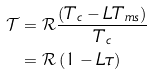Convert formula to latex. <formula><loc_0><loc_0><loc_500><loc_500>\mathcal { T } & = \mathcal { R } \frac { \left ( T _ { c } - L T _ { m s } \right ) } { T _ { c } } \\ & = \mathcal { R } \left ( 1 - L \tau \right )</formula> 